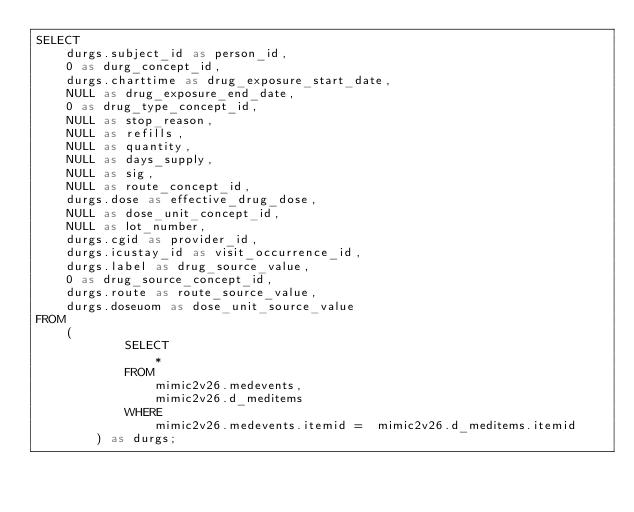<code> <loc_0><loc_0><loc_500><loc_500><_SQL_>SELECT  
    durgs.subject_id as person_id, 
    0 as durg_concept_id, 
    durgs.charttime as drug_exposure_start_date, 
    NULL as drug_exposure_end_date,
    0 as drug_type_concept_id,
    NULL as stop_reason,
    NULL as refills,
    NULL as quantity,
    NULL as days_supply,
    NULL as sig,
    NULL as route_concept_id,
    durgs.dose as effective_drug_dose, 
    NULL as dose_unit_concept_id,
    NULL as lot_number,
    durgs.cgid as provider_id, 
    durgs.icustay_id as visit_occurrence_id,
    durgs.label as drug_source_value, 
    0 as drug_source_concept_id, 
    durgs.route as route_source_value, 
    durgs.doseuom as dose_unit_source_value
FROM
    (
            SELECT 
                * 
            FROM 
                mimic2v26.medevents, 
                mimic2v26.d_meditems
            WHERE 
                mimic2v26.medevents.itemid =  mimic2v26.d_meditems.itemid
        ) as durgs;


</code> 